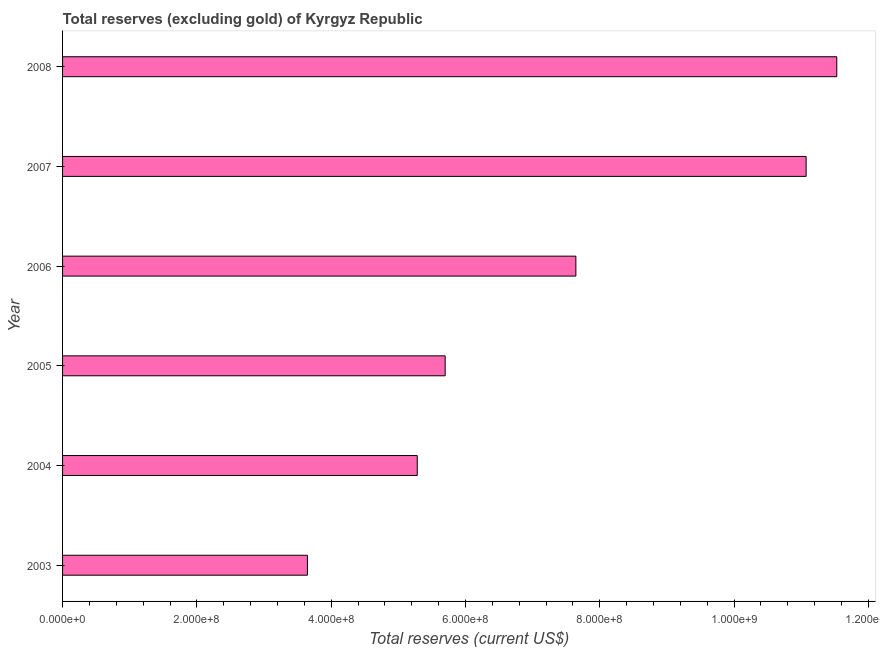Does the graph contain any zero values?
Ensure brevity in your answer.  No. Does the graph contain grids?
Make the answer very short. No. What is the title of the graph?
Keep it short and to the point. Total reserves (excluding gold) of Kyrgyz Republic. What is the label or title of the X-axis?
Give a very brief answer. Total reserves (current US$). What is the total reserves (excluding gold) in 2008?
Make the answer very short. 1.15e+09. Across all years, what is the maximum total reserves (excluding gold)?
Provide a short and direct response. 1.15e+09. Across all years, what is the minimum total reserves (excluding gold)?
Make the answer very short. 3.65e+08. What is the sum of the total reserves (excluding gold)?
Offer a very short reply. 4.49e+09. What is the difference between the total reserves (excluding gold) in 2006 and 2007?
Your answer should be compact. -3.43e+08. What is the average total reserves (excluding gold) per year?
Your answer should be very brief. 7.48e+08. What is the median total reserves (excluding gold)?
Provide a short and direct response. 6.67e+08. In how many years, is the total reserves (excluding gold) greater than 1000000000 US$?
Keep it short and to the point. 2. Do a majority of the years between 2003 and 2005 (inclusive) have total reserves (excluding gold) greater than 840000000 US$?
Provide a succinct answer. No. What is the ratio of the total reserves (excluding gold) in 2003 to that in 2006?
Offer a terse response. 0.48. Is the total reserves (excluding gold) in 2005 less than that in 2008?
Offer a very short reply. Yes. Is the difference between the total reserves (excluding gold) in 2003 and 2006 greater than the difference between any two years?
Ensure brevity in your answer.  No. What is the difference between the highest and the second highest total reserves (excluding gold)?
Keep it short and to the point. 4.56e+07. Is the sum of the total reserves (excluding gold) in 2003 and 2008 greater than the maximum total reserves (excluding gold) across all years?
Your answer should be very brief. Yes. What is the difference between the highest and the lowest total reserves (excluding gold)?
Your response must be concise. 7.88e+08. How many bars are there?
Make the answer very short. 6. Are all the bars in the graph horizontal?
Your answer should be very brief. Yes. How many years are there in the graph?
Provide a short and direct response. 6. What is the difference between two consecutive major ticks on the X-axis?
Provide a short and direct response. 2.00e+08. What is the Total reserves (current US$) in 2003?
Your answer should be very brief. 3.65e+08. What is the Total reserves (current US$) in 2004?
Provide a succinct answer. 5.28e+08. What is the Total reserves (current US$) in 2005?
Keep it short and to the point. 5.70e+08. What is the Total reserves (current US$) in 2006?
Your answer should be very brief. 7.64e+08. What is the Total reserves (current US$) in 2007?
Make the answer very short. 1.11e+09. What is the Total reserves (current US$) of 2008?
Make the answer very short. 1.15e+09. What is the difference between the Total reserves (current US$) in 2003 and 2004?
Provide a short and direct response. -1.64e+08. What is the difference between the Total reserves (current US$) in 2003 and 2005?
Provide a short and direct response. -2.05e+08. What is the difference between the Total reserves (current US$) in 2003 and 2006?
Your answer should be compact. -4.00e+08. What is the difference between the Total reserves (current US$) in 2003 and 2007?
Your response must be concise. -7.43e+08. What is the difference between the Total reserves (current US$) in 2003 and 2008?
Provide a succinct answer. -7.88e+08. What is the difference between the Total reserves (current US$) in 2004 and 2005?
Your answer should be very brief. -4.16e+07. What is the difference between the Total reserves (current US$) in 2004 and 2006?
Provide a succinct answer. -2.36e+08. What is the difference between the Total reserves (current US$) in 2004 and 2007?
Make the answer very short. -5.79e+08. What is the difference between the Total reserves (current US$) in 2004 and 2008?
Make the answer very short. -6.25e+08. What is the difference between the Total reserves (current US$) in 2005 and 2006?
Offer a terse response. -1.95e+08. What is the difference between the Total reserves (current US$) in 2005 and 2007?
Provide a short and direct response. -5.37e+08. What is the difference between the Total reserves (current US$) in 2005 and 2008?
Make the answer very short. -5.83e+08. What is the difference between the Total reserves (current US$) in 2006 and 2007?
Make the answer very short. -3.43e+08. What is the difference between the Total reserves (current US$) in 2006 and 2008?
Offer a terse response. -3.89e+08. What is the difference between the Total reserves (current US$) in 2007 and 2008?
Offer a terse response. -4.56e+07. What is the ratio of the Total reserves (current US$) in 2003 to that in 2004?
Your answer should be very brief. 0.69. What is the ratio of the Total reserves (current US$) in 2003 to that in 2005?
Your answer should be compact. 0.64. What is the ratio of the Total reserves (current US$) in 2003 to that in 2006?
Your answer should be very brief. 0.48. What is the ratio of the Total reserves (current US$) in 2003 to that in 2007?
Your response must be concise. 0.33. What is the ratio of the Total reserves (current US$) in 2003 to that in 2008?
Ensure brevity in your answer.  0.32. What is the ratio of the Total reserves (current US$) in 2004 to that in 2005?
Give a very brief answer. 0.93. What is the ratio of the Total reserves (current US$) in 2004 to that in 2006?
Provide a succinct answer. 0.69. What is the ratio of the Total reserves (current US$) in 2004 to that in 2007?
Offer a very short reply. 0.48. What is the ratio of the Total reserves (current US$) in 2004 to that in 2008?
Offer a terse response. 0.46. What is the ratio of the Total reserves (current US$) in 2005 to that in 2006?
Provide a succinct answer. 0.74. What is the ratio of the Total reserves (current US$) in 2005 to that in 2007?
Offer a very short reply. 0.52. What is the ratio of the Total reserves (current US$) in 2005 to that in 2008?
Offer a terse response. 0.49. What is the ratio of the Total reserves (current US$) in 2006 to that in 2007?
Ensure brevity in your answer.  0.69. What is the ratio of the Total reserves (current US$) in 2006 to that in 2008?
Provide a succinct answer. 0.66. What is the ratio of the Total reserves (current US$) in 2007 to that in 2008?
Make the answer very short. 0.96. 